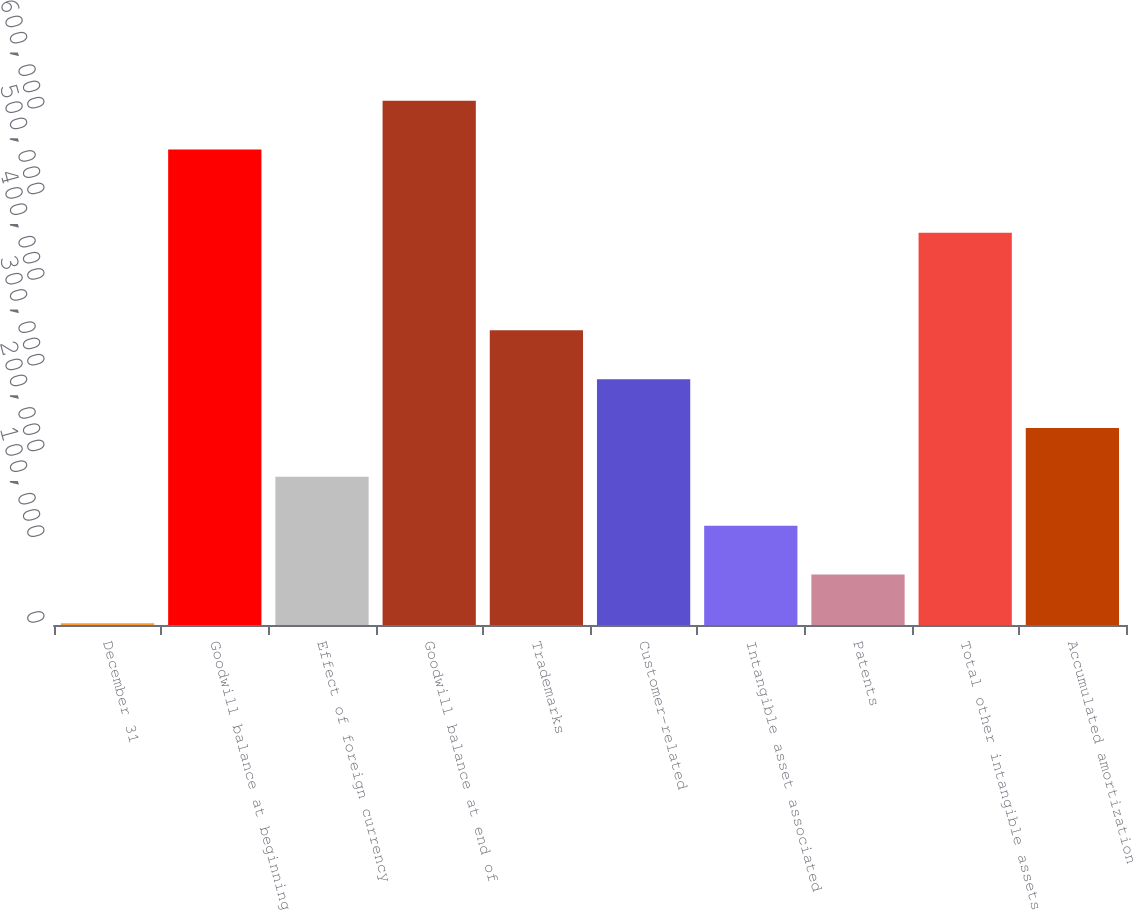Convert chart. <chart><loc_0><loc_0><loc_500><loc_500><bar_chart><fcel>December 31<fcel>Goodwill balance at beginning<fcel>Effect of foreign currency<fcel>Goodwill balance at end of<fcel>Trademarks<fcel>Customer-related<fcel>Intangible asset associated<fcel>Patents<fcel>Total other intangible assets<fcel>Accumulated amortization<nl><fcel>2009<fcel>554677<fcel>172880<fcel>611634<fcel>343752<fcel>286794<fcel>115923<fcel>58966.1<fcel>457666<fcel>229837<nl></chart> 